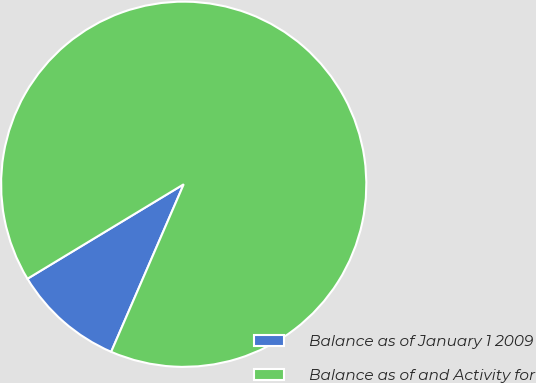Convert chart. <chart><loc_0><loc_0><loc_500><loc_500><pie_chart><fcel>Balance as of January 1 2009<fcel>Balance as of and Activity for<nl><fcel>9.84%<fcel>90.16%<nl></chart> 